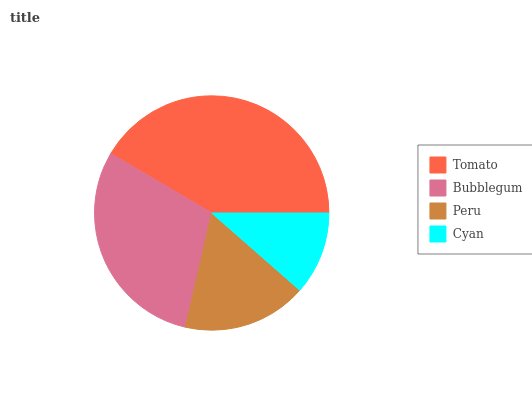Is Cyan the minimum?
Answer yes or no. Yes. Is Tomato the maximum?
Answer yes or no. Yes. Is Bubblegum the minimum?
Answer yes or no. No. Is Bubblegum the maximum?
Answer yes or no. No. Is Tomato greater than Bubblegum?
Answer yes or no. Yes. Is Bubblegum less than Tomato?
Answer yes or no. Yes. Is Bubblegum greater than Tomato?
Answer yes or no. No. Is Tomato less than Bubblegum?
Answer yes or no. No. Is Bubblegum the high median?
Answer yes or no. Yes. Is Peru the low median?
Answer yes or no. Yes. Is Cyan the high median?
Answer yes or no. No. Is Bubblegum the low median?
Answer yes or no. No. 